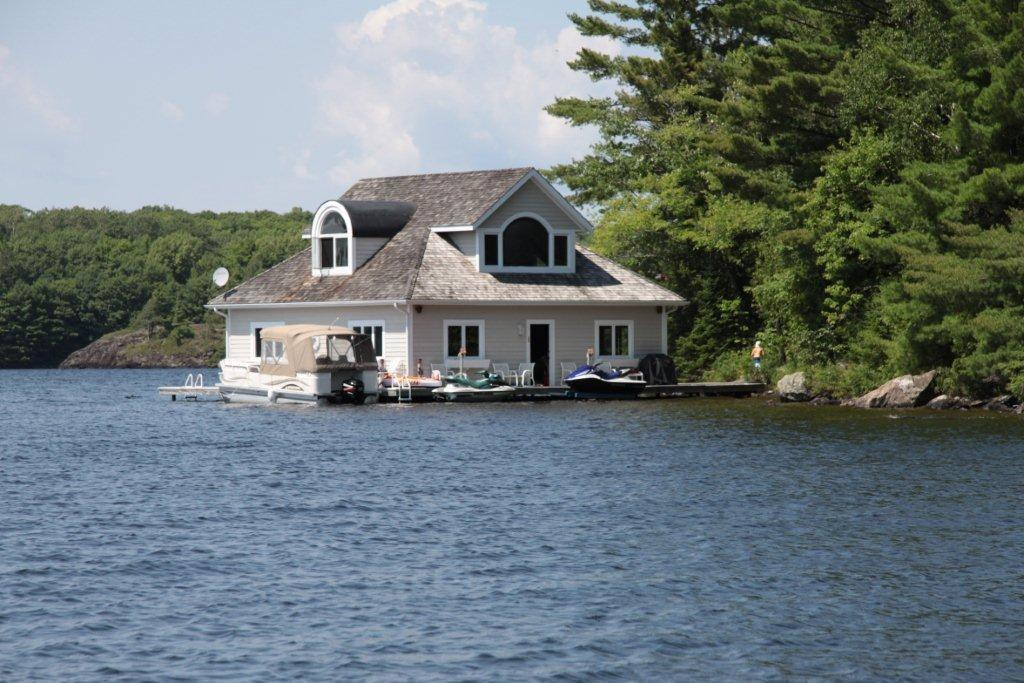What is the primary element visible in the image? There is water in the image. What type of structure can be seen in the image? There is a house in the image. What type of furniture is present in the image? There are chairs and a table in the image. What mode of transportation is visible in the image? There is a boat in the image. How many people are present in the image? There are two persons in the image. What type of vegetation is present in the image? There are trees in the image. What type of ground surface is visible in the image? There are stones in the image. What part of the natural environment is visible in the image? The sky is visible in the image. Based on the presence of sunlight and shadows, when do you think the image was likely taken? The image was likely taken during the day. What type of rice is being cooked in the pot on the table in the image? There is no pot or rice present in the image; the table has a tablecloth and a vase with flowers on it. 